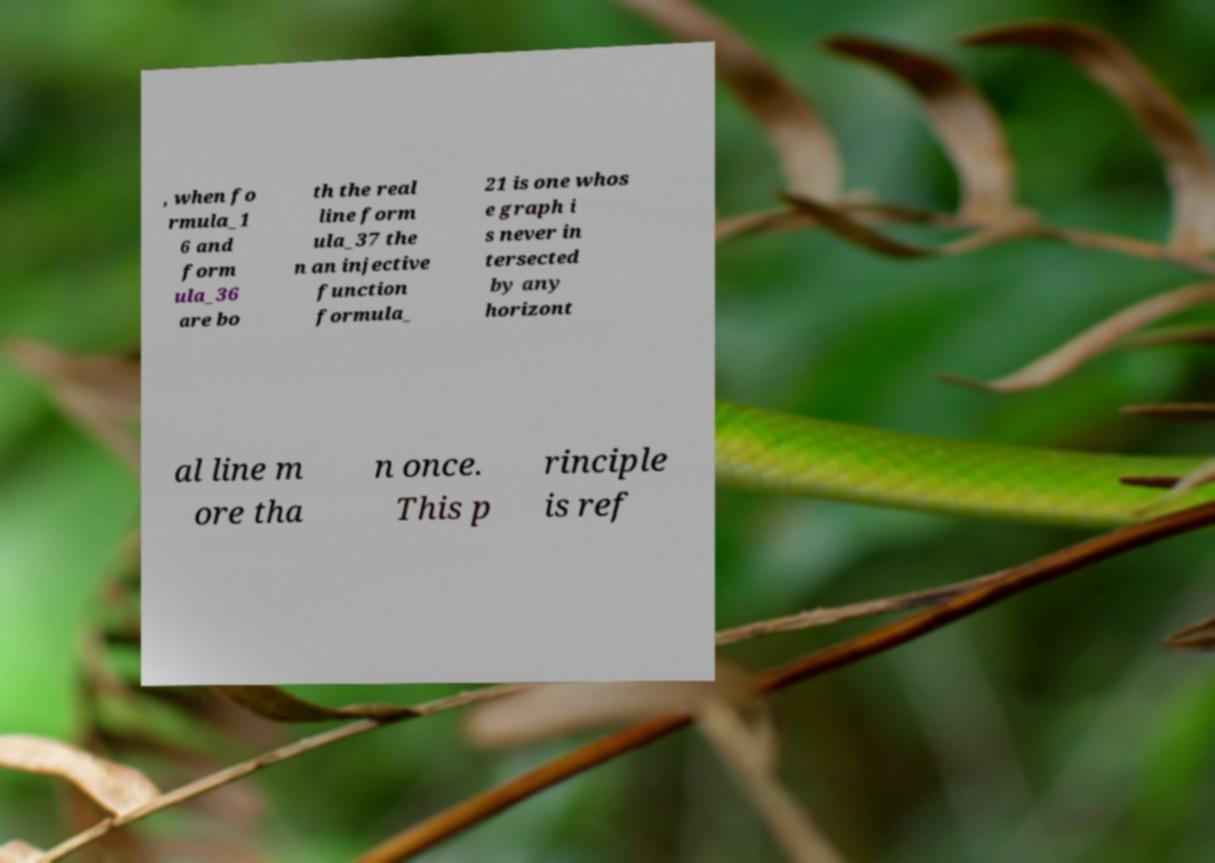I need the written content from this picture converted into text. Can you do that? , when fo rmula_1 6 and form ula_36 are bo th the real line form ula_37 the n an injective function formula_ 21 is one whos e graph i s never in tersected by any horizont al line m ore tha n once. This p rinciple is ref 